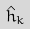<formula> <loc_0><loc_0><loc_500><loc_500>\hat { h } _ { k }</formula> 